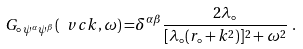Convert formula to latex. <formula><loc_0><loc_0><loc_500><loc_500>G _ { \circ \, \psi ^ { \alpha } \psi ^ { \beta } } ( { \ v c k } , \omega ) = & \delta ^ { \alpha \beta } \frac { 2 \lambda _ { \circ } } { [ \lambda _ { \circ } ( r _ { \circ } + k ^ { 2 } ) ] ^ { 2 } + \omega ^ { 2 } } \ .</formula> 